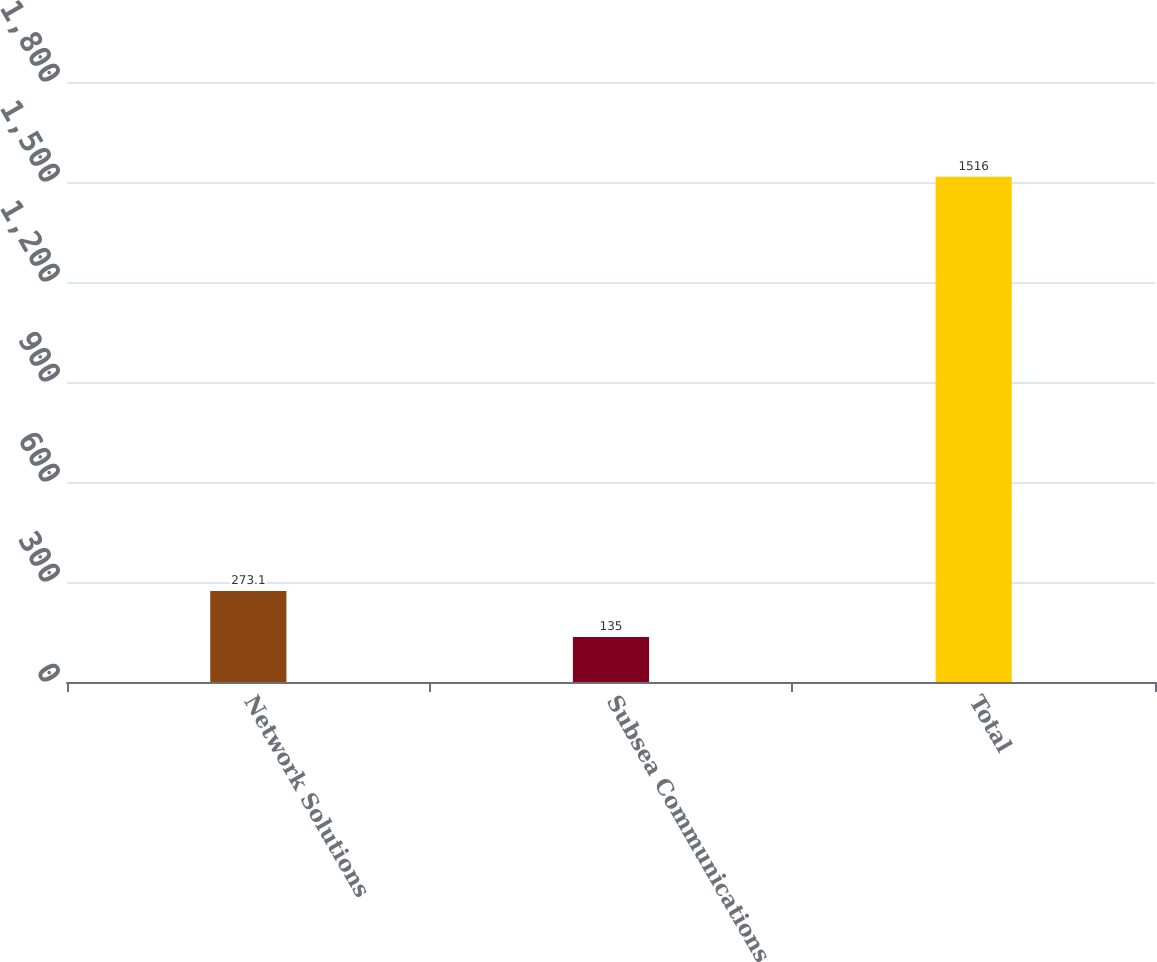Convert chart. <chart><loc_0><loc_0><loc_500><loc_500><bar_chart><fcel>Network Solutions<fcel>Subsea Communications<fcel>Total<nl><fcel>273.1<fcel>135<fcel>1516<nl></chart> 